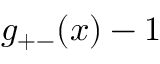Convert formula to latex. <formula><loc_0><loc_0><loc_500><loc_500>g _ { + - } ( x ) - 1</formula> 